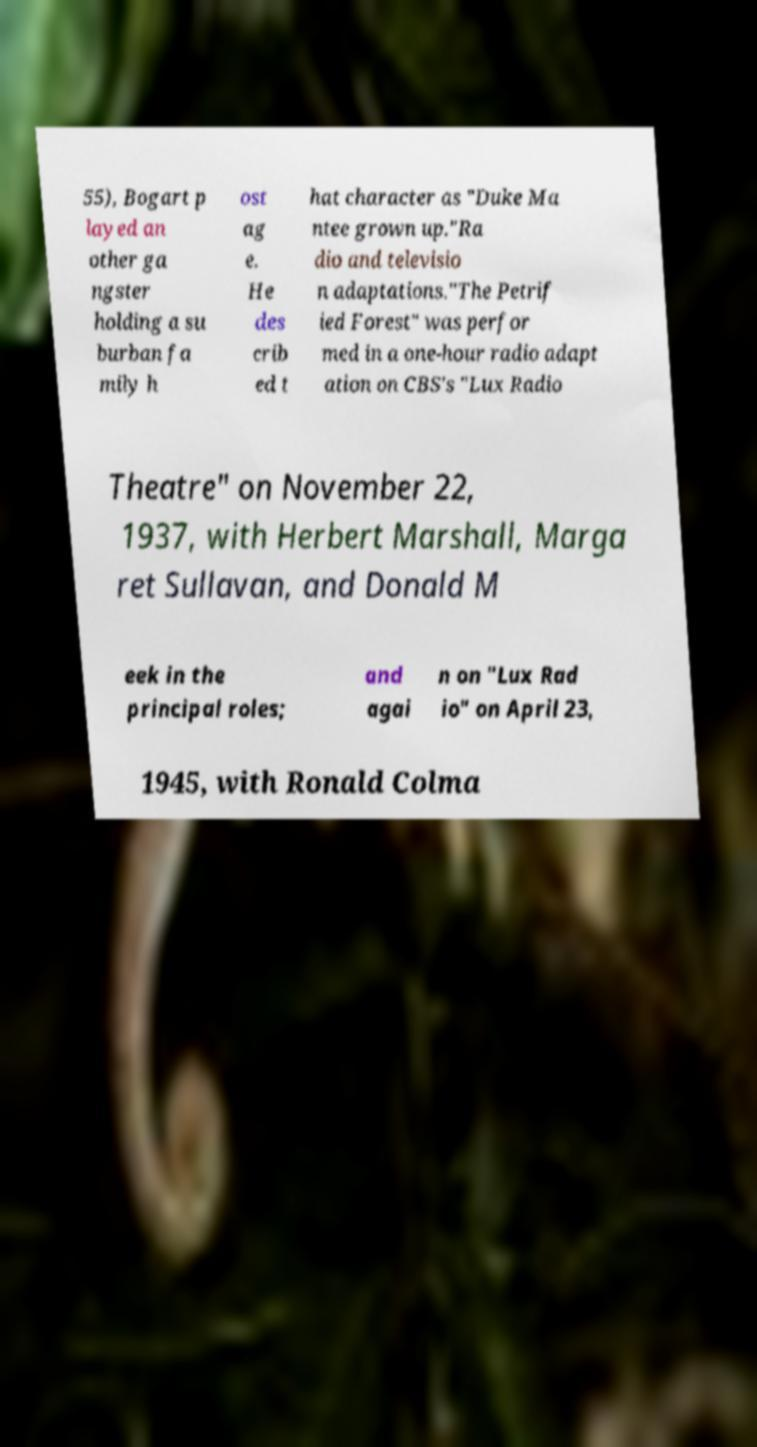Please identify and transcribe the text found in this image. 55), Bogart p layed an other ga ngster holding a su burban fa mily h ost ag e. He des crib ed t hat character as "Duke Ma ntee grown up."Ra dio and televisio n adaptations."The Petrif ied Forest" was perfor med in a one-hour radio adapt ation on CBS's "Lux Radio Theatre" on November 22, 1937, with Herbert Marshall, Marga ret Sullavan, and Donald M eek in the principal roles; and agai n on "Lux Rad io" on April 23, 1945, with Ronald Colma 